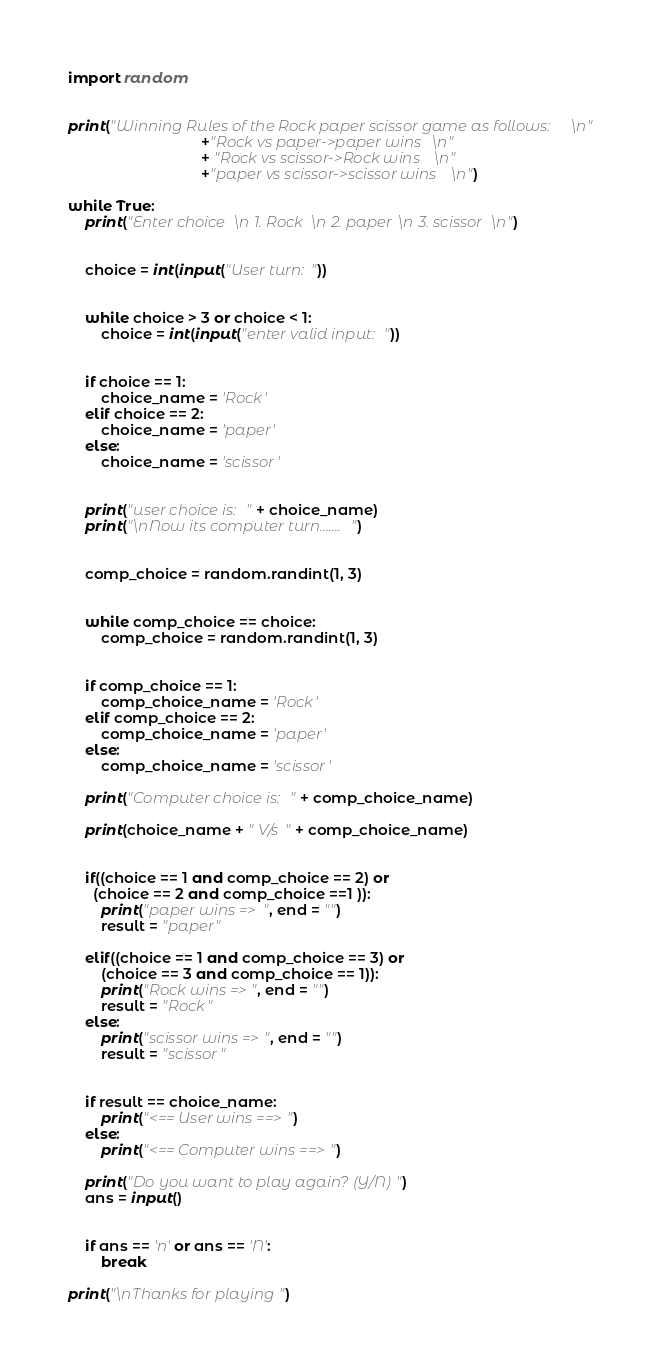Convert code to text. <code><loc_0><loc_0><loc_500><loc_500><_Python_>import random
  

print("Winning Rules of the Rock paper scissor game as follows: \n"
                                +"Rock vs paper->paper wins \n"
                                + "Rock vs scissor->Rock wins \n"
                                +"paper vs scissor->scissor wins \n")
  
while True:
    print("Enter choice \n 1. Rock \n 2. paper \n 3. scissor \n")
      

    choice = int(input("User turn: "))
  

    while choice > 3 or choice < 1:
        choice = int(input("enter valid input: "))
          

    if choice == 1:
        choice_name = 'Rock'
    elif choice == 2:
        choice_name = 'paper'
    else:
        choice_name = 'scissor'
          

    print("user choice is: " + choice_name)
    print("\nNow its computer turn.......")
  

    comp_choice = random.randint(1, 3)
      

    while comp_choice == choice:
        comp_choice = random.randint(1, 3)
  

    if comp_choice == 1:
        comp_choice_name = 'Rock'
    elif comp_choice == 2:
        comp_choice_name = 'paper'
    else:
        comp_choice_name = 'scissor'
          
    print("Computer choice is: " + comp_choice_name)
  
    print(choice_name + " V/s " + comp_choice_name)
  

    if((choice == 1 and comp_choice == 2) or
      (choice == 2 and comp_choice ==1 )):
        print("paper wins => ", end = "")
        result = "paper"
          
    elif((choice == 1 and comp_choice == 3) or
        (choice == 3 and comp_choice == 1)):
        print("Rock wins =>", end = "")
        result = "Rock"
    else:
        print("scissor wins =>", end = "")
        result = "scissor"
  

    if result == choice_name:
        print("<== User wins ==>")
    else:
        print("<== Computer wins ==>")
          
    print("Do you want to play again? (Y/N)")
    ans = input()
  

    if ans == 'n' or ans == 'N':
        break

print("\nThanks for playing")
</code> 